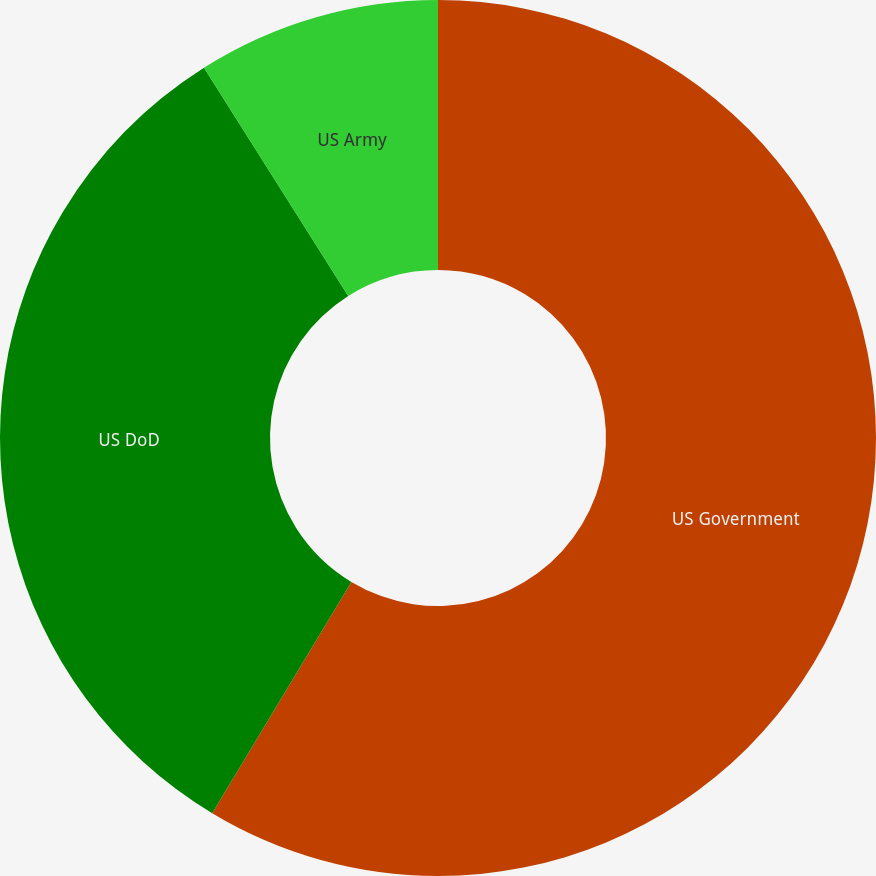<chart> <loc_0><loc_0><loc_500><loc_500><pie_chart><fcel>US Government<fcel>US DoD<fcel>US Army<nl><fcel>58.62%<fcel>32.41%<fcel>8.97%<nl></chart> 